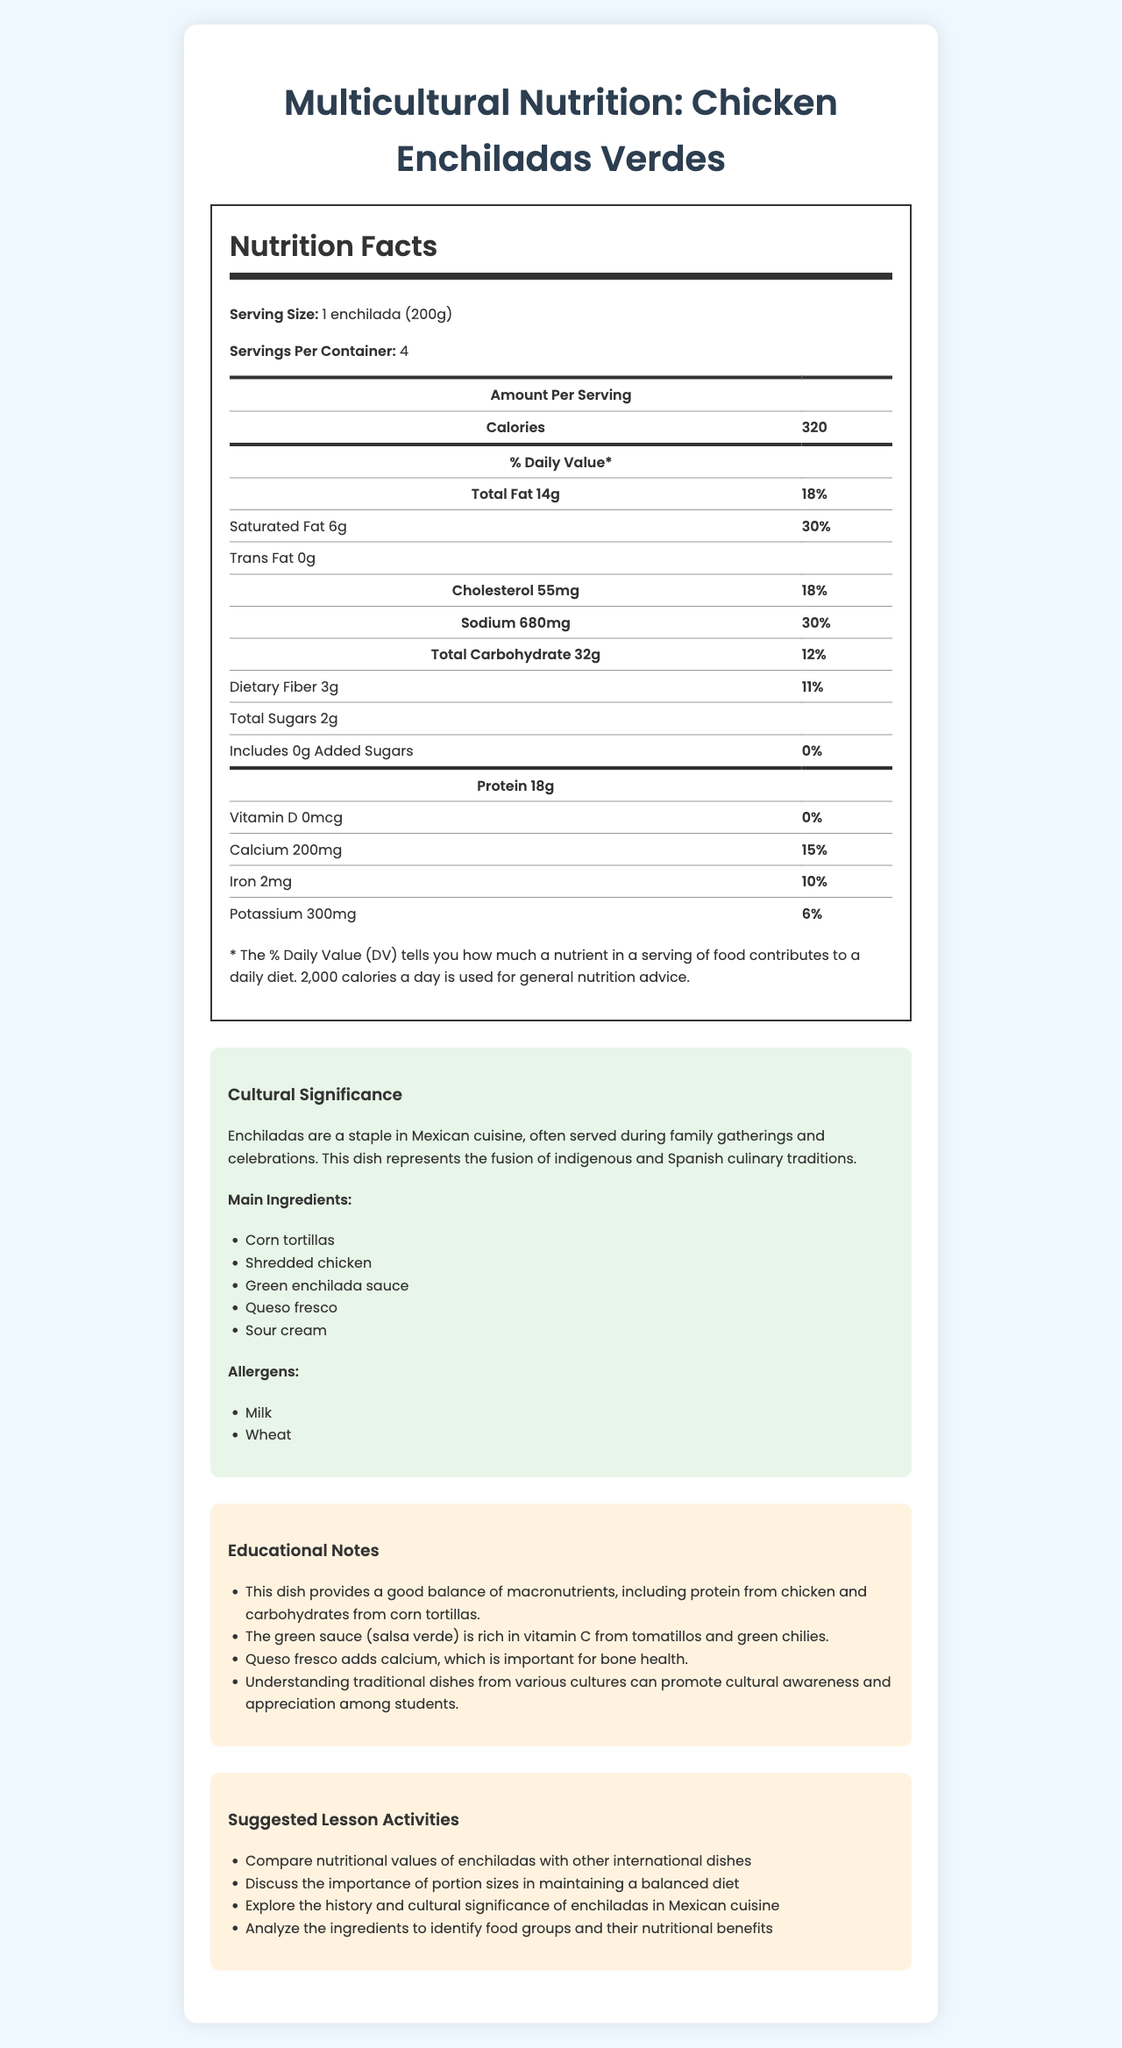what is the serving size for Chicken Enchiladas Verdes? The serving size is stated at the beginning of the Nutrition Facts section on the document.
Answer: 1 enchilada (200g) how many calories are there per serving? The number of calories per serving is listed in the Amount Per Serving section.
Answer: 320 what is the percentage of the daily value of total fat per serving? The percentage of the daily value of total fat per serving is provided in the % Daily Value section.
Answer: 18% how much protein is in one serving? The amount of protein per serving is listed in the macronutrient breakdown.
Answer: 18g what main ingredients are used to make Chicken Enchiladas Verdes? The main ingredients are listed under the cultural information.
Answer: Corn tortillas, Shredded chicken, Green enchilada sauce, Queso fresco, Sour cream which of the following is an allergen in this dish? A. Peanuts B. Milk C. Soy D. Fish The allergens section indicates that milk is an allergen in this dish.
Answer: B what percentage of the daily value of calcium is provided per serving? It is listed in the nutrition facts under calcium.
Answer: 15% is there any trans fat in Chicken Enchiladas Verdes? The amount of trans fat is listed as 0g in the nutrition facts.
Answer: No which dish is this document detailing? A. Tacos B. Chicken Enchiladas Verdes C. Burritos The document title and several references within the document specify Chicken Enchiladas Verdes.
Answer: B how much cholesterol is in each serving? The amount of cholesterol per serving is listed in the Nutrition Facts section.
Answer: 55mg how does this dish support cultural awareness and appreciation among students? The educational notes mention that this dish promotes cultural awareness and appreciation among students by understanding traditional dishes.
Answer: By understanding traditional dishes from various cultures, such as the Chicken Enchiladas Verdes, students can learn about cultural significance and culinary diversity. what is the cultural significance of Chicken Enchiladas Verdes? The explanation of the cultural significance is provided in the cultural information section of the document.
Answer: Enchiladas are a staple in Mexican cuisine, often served during family gatherings and celebrations. This dish represents the fusion of indigenous and Spanish culinary traditions. estimate the total number of calories in the entire container of Chicken Enchiladas Verdes. There are 320 calories per serving and 4 servings per container. 320 calories/serving * 4 servings = 1,280 calories.
Answer: 1,280 calories describe the primary purpose and content of the document. The document includes comprehensive nutritional data, cultural relevance, educational insights, and activity suggestions.
Answer: The document presents detailed nutritional information for Chicken Enchiladas Verdes, a traditional Mexican dish, including calorie and macronutrient breakdowns. It also explores the cultural significance of the dish, lists main ingredients and allergens, provides educational notes, and suggests lesson activities to promote cultural awareness and healthy eating among students. list two suggested lesson activities mentioned in the document. These activities are listed in the Suggested Lesson Activities section.
Answer: Compare nutritional values of enchiladas with other international dishes; Discuss the importance of portion sizes in maintaining a balanced diet what quantity of dietary fiber is in each enchilada? Dietary fiber per serving is listed in the Nutrition Facts section.
Answer: 3g does this dish include any added sugars? The amount of added sugars is listed as 0g in the Nutrition Facts section.
Answer: No what is the serving size in grams? The serving size, converted to grams, is listed as 200g in the Nutrition Facts section.
Answer: 200g what specific health benefits do tomatillos and green chilies provide in this dish? The document mentions that the green sauce (salsa verde) is rich in vitamin C from tomatillos and green chilies, but does not detail specific health benefits.
Answer: Not enough information 